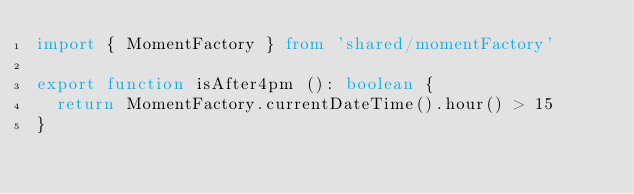Convert code to text. <code><loc_0><loc_0><loc_500><loc_500><_TypeScript_>import { MomentFactory } from 'shared/momentFactory'

export function isAfter4pm (): boolean {
  return MomentFactory.currentDateTime().hour() > 15
}
</code> 